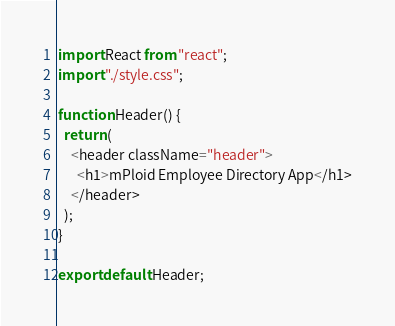Convert code to text. <code><loc_0><loc_0><loc_500><loc_500><_TypeScript_>import React from "react";
import "./style.css";

function Header() {
  return (
    <header className="header">
      <h1>mPloid Employee Directory App</h1>
    </header>
  );
}

export default Header;</code> 